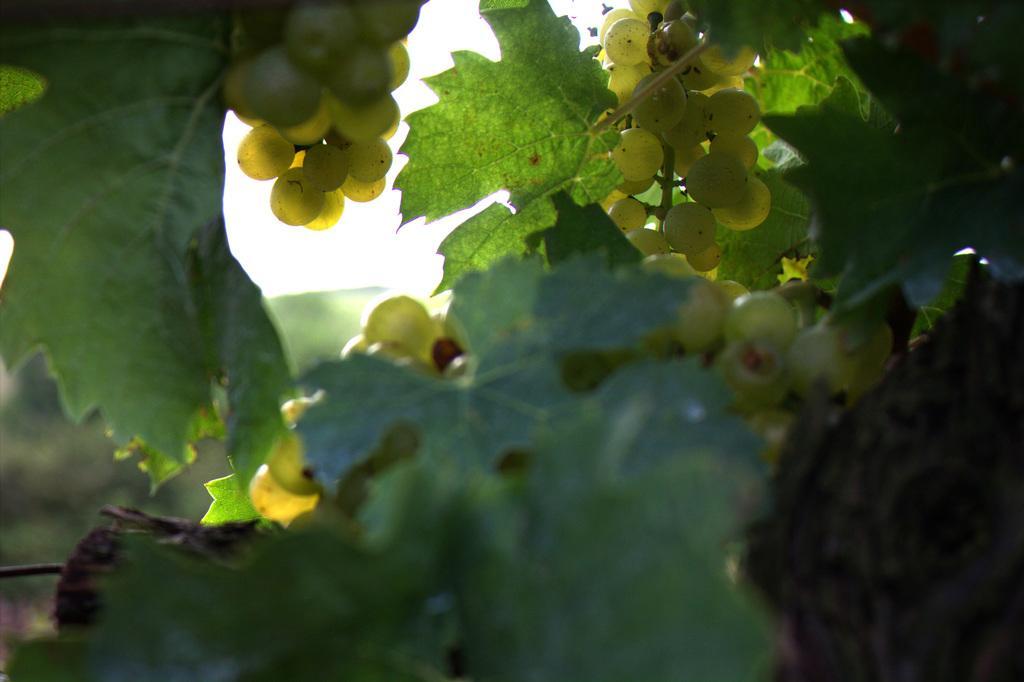Please provide a concise description of this image. In the image there are grapes to a grape plant. 